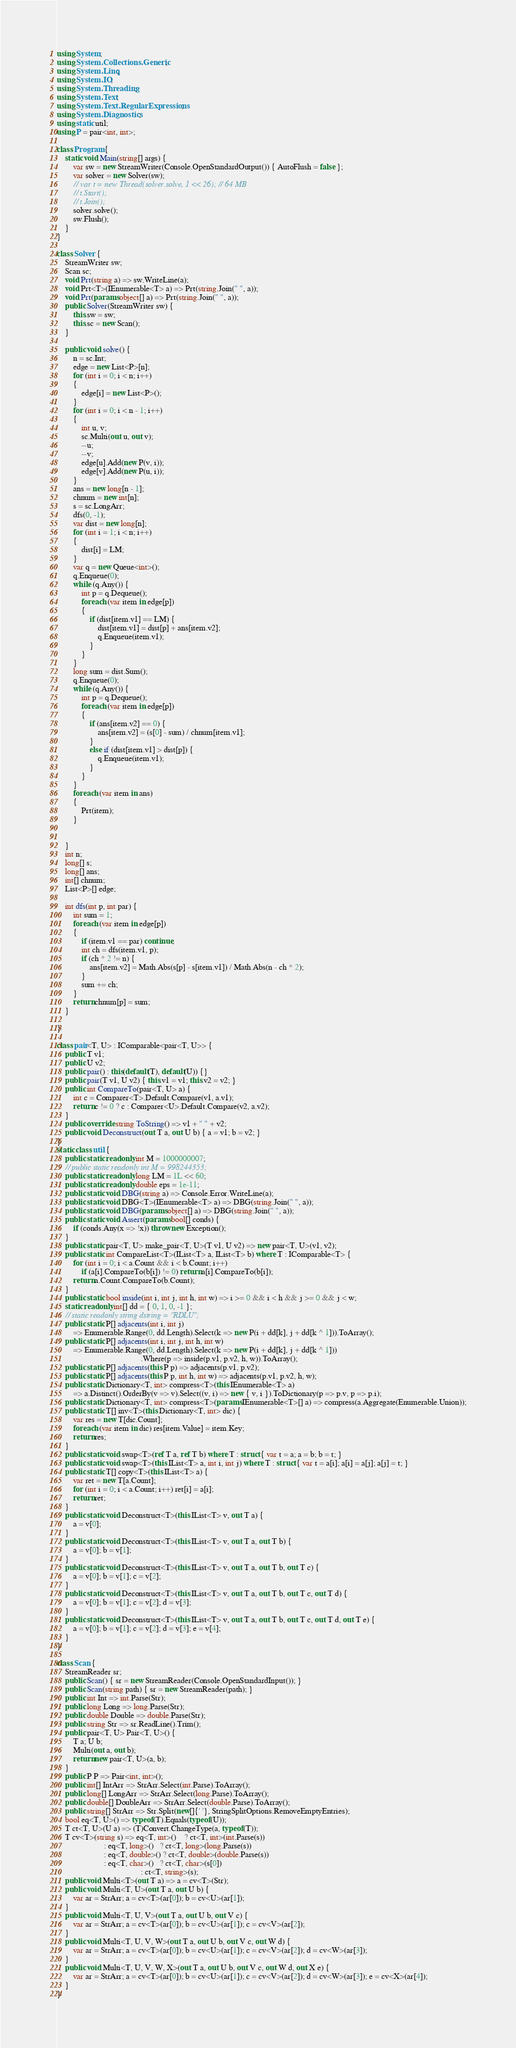Convert code to text. <code><loc_0><loc_0><loc_500><loc_500><_C#_>using System;
using System.Collections.Generic;
using System.Linq;
using System.IO;
using System.Threading;
using System.Text;
using System.Text.RegularExpressions;
using System.Diagnostics;
using static util;
using P = pair<int, int>;

class Program {
    static void Main(string[] args) {
        var sw = new StreamWriter(Console.OpenStandardOutput()) { AutoFlush = false };
        var solver = new Solver(sw);
        // var t = new Thread(solver.solve, 1 << 26); // 64 MB
        // t.Start();
        // t.Join();
        solver.solve();
        sw.Flush();
    }
}

class Solver {
    StreamWriter sw;
    Scan sc;
    void Prt(string a) => sw.WriteLine(a);
    void Prt<T>(IEnumerable<T> a) => Prt(string.Join(" ", a));
    void Prt(params object[] a) => Prt(string.Join(" ", a));
    public Solver(StreamWriter sw) {
        this.sw = sw;
        this.sc = new Scan();
    }

    public void solve() {
        n = sc.Int;
        edge = new List<P>[n];
        for (int i = 0; i < n; i++)
        {
            edge[i] = new List<P>();
        }
        for (int i = 0; i < n - 1; i++)
        {
            int u, v;
            sc.Multi(out u, out v);
            --u;
            --v;
            edge[u].Add(new P(v, i));
            edge[v].Add(new P(u, i));
        }
        ans = new long[n - 1];
        chnum = new int[n];
        s = sc.LongArr;
        dfs(0, -1);
        var dist = new long[n];
        for (int i = 1; i < n; i++)
        {
            dist[i] = LM;
        }
        var q = new Queue<int>();
        q.Enqueue(0);
        while (q.Any()) {
            int p = q.Dequeue();
            foreach (var item in edge[p])
            {
                if (dist[item.v1] == LM) {
                    dist[item.v1] = dist[p] + ans[item.v2];
                    q.Enqueue(item.v1);
                }
            }
        }
        long sum = dist.Sum();
        q.Enqueue(0);
        while (q.Any()) {
            int p = q.Dequeue();
            foreach (var item in edge[p])
            {
                if (ans[item.v2] == 0) {
                    ans[item.v2] = (s[0] - sum) / chnum[item.v1];
                }
                else if (dist[item.v1] > dist[p]) {
                    q.Enqueue(item.v1);
                }
            }
        }
        foreach (var item in ans)
        {
            Prt(item);
        }


    }
    int n;
    long[] s;
    long[] ans;
    int[] chnum;
    List<P>[] edge;

    int dfs(int p, int par) {
        int sum = 1;
        foreach (var item in edge[p])
        {
            if (item.v1 == par) continue;
            int ch = dfs(item.v1, p);
            if (ch * 2 != n) {
                ans[item.v2] = Math.Abs(s[p] - s[item.v1]) / Math.Abs(n - ch * 2);
            }
            sum += ch;
        }
        return chnum[p] = sum;
    }

}

class pair<T, U> : IComparable<pair<T, U>> {
    public T v1;
    public U v2;
    public pair() : this(default(T), default(U)) {}
    public pair(T v1, U v2) { this.v1 = v1; this.v2 = v2; }
    public int CompareTo(pair<T, U> a) {
        int c = Comparer<T>.Default.Compare(v1, a.v1);
        return c != 0 ? c : Comparer<U>.Default.Compare(v2, a.v2);
    }
    public override string ToString() => v1 + " " + v2;
    public void Deconstruct(out T a, out U b) { a = v1; b = v2; }
}
static class util {
    public static readonly int M = 1000000007;
    // public static readonly int M = 998244353;
    public static readonly long LM = 1L << 60;
    public static readonly double eps = 1e-11;
    public static void DBG(string a) => Console.Error.WriteLine(a);
    public static void DBG<T>(IEnumerable<T> a) => DBG(string.Join(" ", a));
    public static void DBG(params object[] a) => DBG(string.Join(" ", a));
    public static void Assert(params bool[] conds) {
        if (conds.Any(x => !x)) throw new Exception();
    }
    public static pair<T, U> make_pair<T, U>(T v1, U v2) => new pair<T, U>(v1, v2);
    public static int CompareList<T>(IList<T> a, IList<T> b) where T : IComparable<T> {
        for (int i = 0; i < a.Count && i < b.Count; i++)
            if (a[i].CompareTo(b[i]) != 0) return a[i].CompareTo(b[i]);
        return a.Count.CompareTo(b.Count);
    }
    public static bool inside(int i, int j, int h, int w) => i >= 0 && i < h && j >= 0 && j < w;
    static readonly int[] dd = { 0, 1, 0, -1 };
    // static readonly string dstring = "RDLU";
    public static P[] adjacents(int i, int j)
        => Enumerable.Range(0, dd.Length).Select(k => new P(i + dd[k], j + dd[k ^ 1])).ToArray();
    public static P[] adjacents(int i, int j, int h, int w)
        => Enumerable.Range(0, dd.Length).Select(k => new P(i + dd[k], j + dd[k ^ 1]))
                                         .Where(p => inside(p.v1, p.v2, h, w)).ToArray();
    public static P[] adjacents(this P p) => adjacents(p.v1, p.v2);
    public static P[] adjacents(this P p, int h, int w) => adjacents(p.v1, p.v2, h, w);
    public static Dictionary<T, int> compress<T>(this IEnumerable<T> a)
        => a.Distinct().OrderBy(v => v).Select((v, i) => new { v, i }).ToDictionary(p => p.v, p => p.i);
    public static Dictionary<T, int> compress<T>(params IEnumerable<T>[] a) => compress(a.Aggregate(Enumerable.Union));
    public static T[] inv<T>(this Dictionary<T, int> dic) {
        var res = new T[dic.Count];
        foreach (var item in dic) res[item.Value] = item.Key;
        return res;
    }
    public static void swap<T>(ref T a, ref T b) where T : struct { var t = a; a = b; b = t; }
    public static void swap<T>(this IList<T> a, int i, int j) where T : struct { var t = a[i]; a[i] = a[j]; a[j] = t; }
    public static T[] copy<T>(this IList<T> a) {
        var ret = new T[a.Count];
        for (int i = 0; i < a.Count; i++) ret[i] = a[i];
        return ret;
    }
    public static void Deconstruct<T>(this IList<T> v, out T a) {
        a = v[0];
    }
    public static void Deconstruct<T>(this IList<T> v, out T a, out T b) {
        a = v[0]; b = v[1];
    }
    public static void Deconstruct<T>(this IList<T> v, out T a, out T b, out T c) {
        a = v[0]; b = v[1]; c = v[2];
    }
    public static void Deconstruct<T>(this IList<T> v, out T a, out T b, out T c, out T d) {
        a = v[0]; b = v[1]; c = v[2]; d = v[3];
    }
    public static void Deconstruct<T>(this IList<T> v, out T a, out T b, out T c, out T d, out T e) {
        a = v[0]; b = v[1]; c = v[2]; d = v[3]; e = v[4];
    }
}

class Scan {
    StreamReader sr;
    public Scan() { sr = new StreamReader(Console.OpenStandardInput()); }
    public Scan(string path) { sr = new StreamReader(path); }
    public int Int => int.Parse(Str);
    public long Long => long.Parse(Str);
    public double Double => double.Parse(Str);
    public string Str => sr.ReadLine().Trim();
    public pair<T, U> Pair<T, U>() {
        T a; U b;
        Multi(out a, out b);
        return new pair<T, U>(a, b);
    }
    public P P => Pair<int, int>();
    public int[] IntArr => StrArr.Select(int.Parse).ToArray();
    public long[] LongArr => StrArr.Select(long.Parse).ToArray();
    public double[] DoubleArr => StrArr.Select(double.Parse).ToArray();
    public string[] StrArr => Str.Split(new[]{' '}, StringSplitOptions.RemoveEmptyEntries);
    bool eq<T, U>() => typeof(T).Equals(typeof(U));
    T ct<T, U>(U a) => (T)Convert.ChangeType(a, typeof(T));
    T cv<T>(string s) => eq<T, int>()    ? ct<T, int>(int.Parse(s))
                       : eq<T, long>()   ? ct<T, long>(long.Parse(s))
                       : eq<T, double>() ? ct<T, double>(double.Parse(s))
                       : eq<T, char>()   ? ct<T, char>(s[0])
                                         : ct<T, string>(s);
    public void Multi<T>(out T a) => a = cv<T>(Str);
    public void Multi<T, U>(out T a, out U b) {
        var ar = StrArr; a = cv<T>(ar[0]); b = cv<U>(ar[1]);
    }
    public void Multi<T, U, V>(out T a, out U b, out V c) {
        var ar = StrArr; a = cv<T>(ar[0]); b = cv<U>(ar[1]); c = cv<V>(ar[2]);
    }
    public void Multi<T, U, V, W>(out T a, out U b, out V c, out W d) {
        var ar = StrArr; a = cv<T>(ar[0]); b = cv<U>(ar[1]); c = cv<V>(ar[2]); d = cv<W>(ar[3]);
    }
    public void Multi<T, U, V, W, X>(out T a, out U b, out V c, out W d, out X e) {
        var ar = StrArr; a = cv<T>(ar[0]); b = cv<U>(ar[1]); c = cv<V>(ar[2]); d = cv<W>(ar[3]); e = cv<X>(ar[4]);
    }
}
</code> 